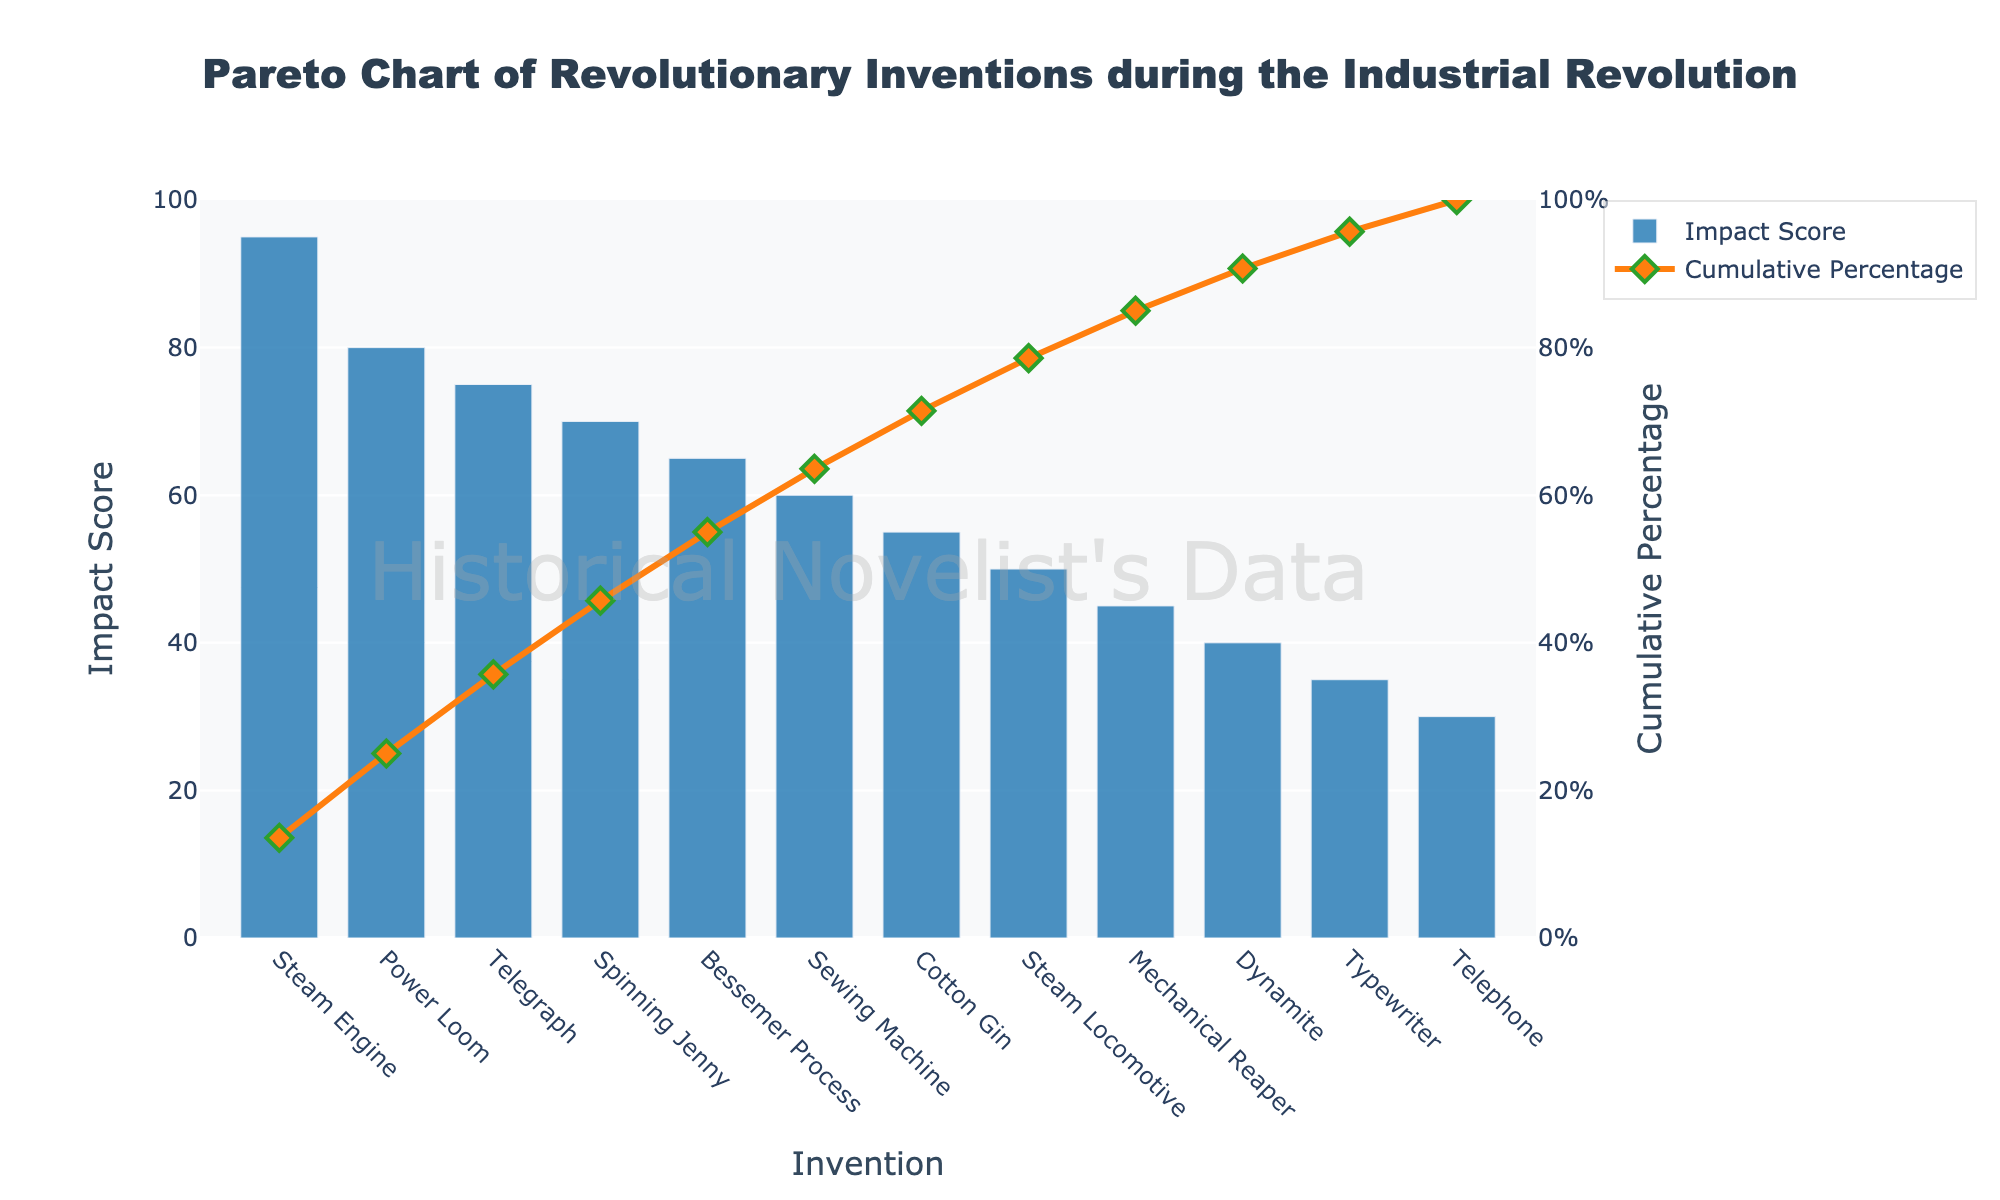What is the title of the chart? The title of the chart is displayed at the top center and reads "Pareto Chart of Revolutionary Inventions during the Industrial Revolution".
Answer: Pareto Chart of Revolutionary Inventions during the Industrial Revolution What are the top three inventions with the highest impact scores? By examining the bars in descending order, the top three inventions are the Steam Engine with 95, Power Loom with 80, and Telegraph with 75.
Answer: Steam Engine, Power Loom, Telegraph What is the impact score of the Telephone? Locate the bar corresponding to the Telephone, which shows an impact score of 30.
Answer: 30 What is the cumulative percentage after adding the impact of the Spinning Jenny? Locate the Spinning Jenny and its impact score (70), then trace the cumulative percentage line at this point, which is approximately 80%.
Answer: Approximately 80% Which invention marks the 50% cumulative percentage threshold? Follow the cumulative percentage line to 50%, which intersects with the Power Loom.
Answer: Power Loom How much higher is the impact score of the Steam Engine compared to the Mechanical Reaper? The impact score of the Steam Engine is 95, and the Mechanical Reaper is 45. The difference is 95 - 45 = 50.
Answer: 50 What percentage of the total impact is contributed by the four highest impact inventions (Steam Engine, Power Loom, Telegraph, Spinning Jenny)? Sum the impact scores (95 + 80 + 75 + 70 = 320) and calculate the cumulative percentage up to Spinning Jenny from the graph, approximately 80%.
Answer: Approximately 80% List the inventions that together contribute to the first 90% of the cumulative impact. From the graph, the cumulative percentage above 90% includes Steam Engine, Power Loom, Telegraph, Spinning Jenny, Bessemer Process, Sewing Machine, and Cotton Gin.
Answer: Steam Engine, Power Loom, Telegraph, Spinning Jenny, Bessemer Process, Sewing Machine, Cotton Gin Which invention has the lowest impact score, and what is it? Identify the shortest bar in the graph, which corresponds to the Telephone, with an impact score of 30.
Answer: Telephone, 30 